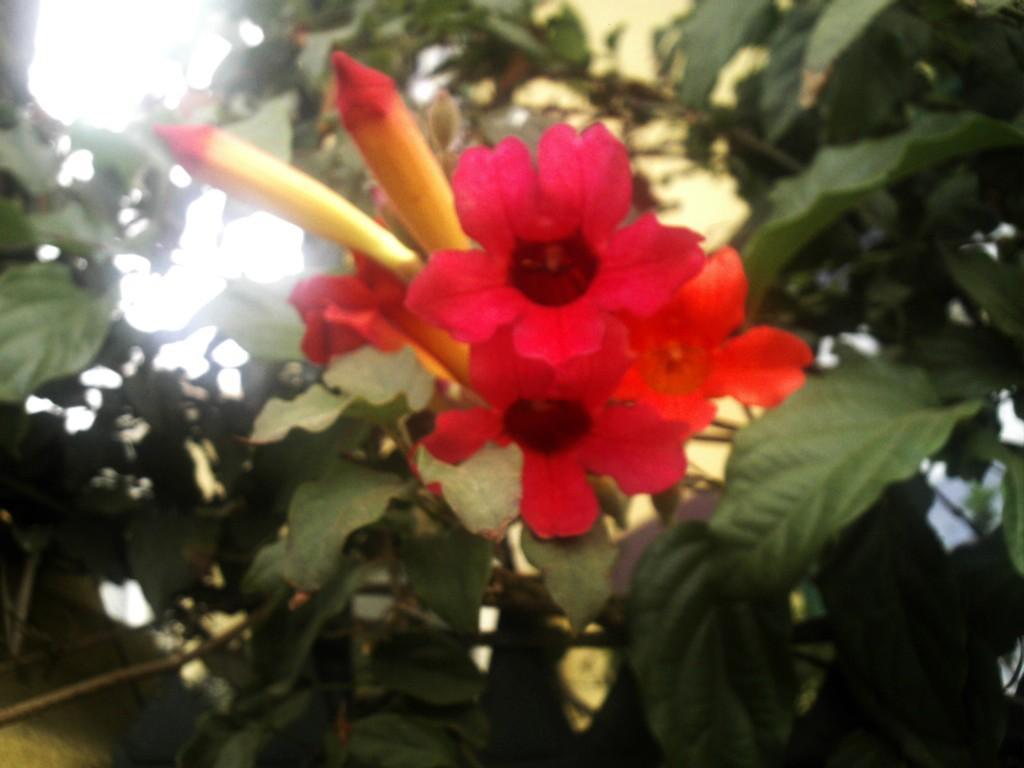Describe this image in one or two sentences. In the center of the image there are flowers. In the background of the image there are leaves. 